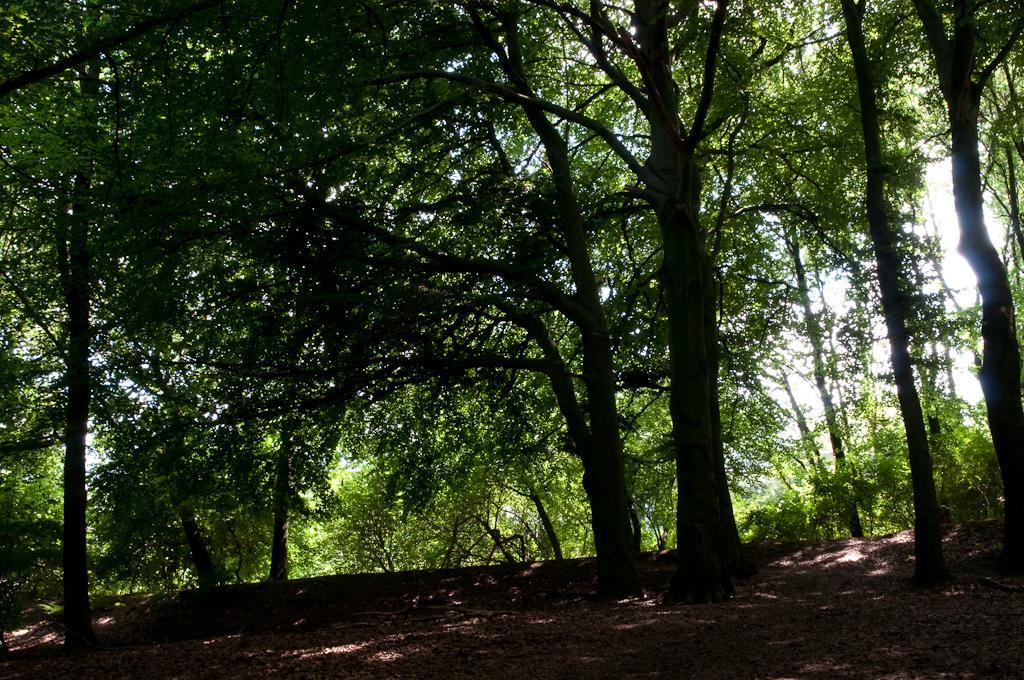In one or two sentences, can you explain what this image depicts? In the image there are trees all over the place on the land. 